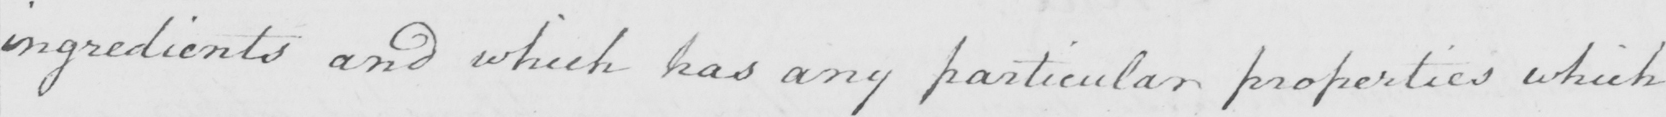What is written in this line of handwriting? ingredients and which has any particular properties which 